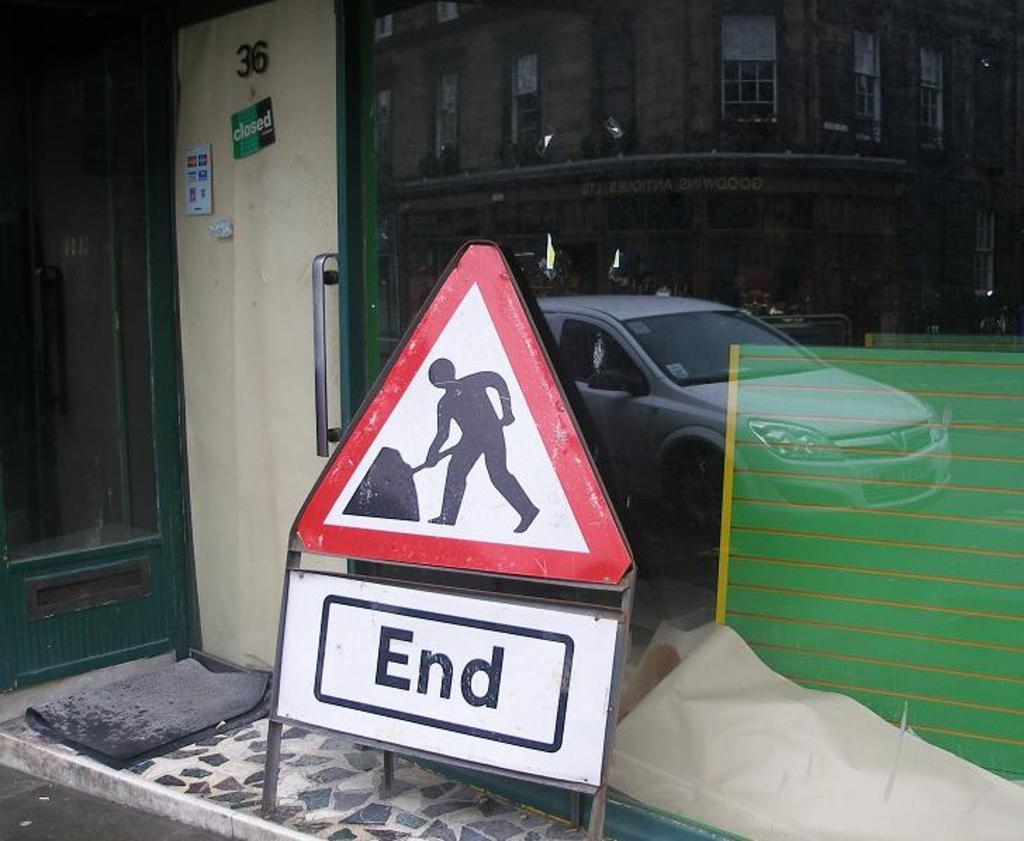<image>
Render a clear and concise summary of the photo. A red, black and white triangle sign says end in a box. 